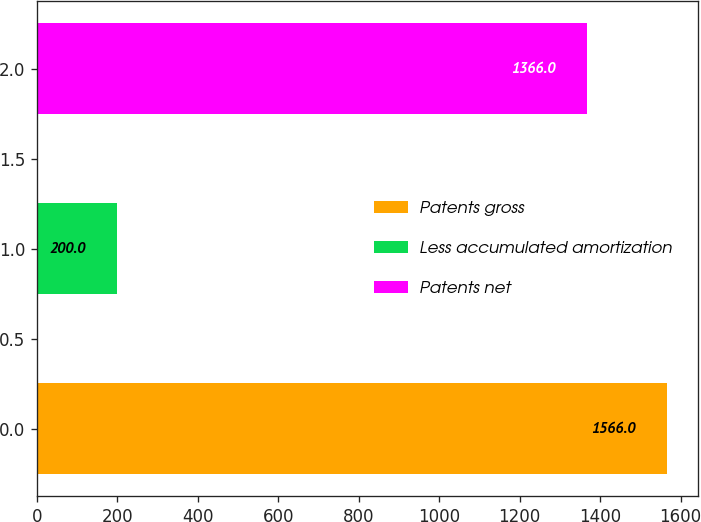Convert chart to OTSL. <chart><loc_0><loc_0><loc_500><loc_500><bar_chart><fcel>Patents gross<fcel>Less accumulated amortization<fcel>Patents net<nl><fcel>1566<fcel>200<fcel>1366<nl></chart> 